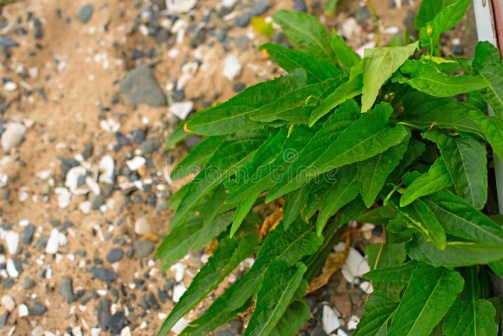Can you describe the plant in more detail? The plant featured in the image has long, slender leaves with pointed tips, showcasing a vibrant green color. Each leaf has a somewhat corrugated texture, which catches the sunlight beautifully and highlights the rich green hues. The leaves are densely packed, growing outward and giving the plant a lush, thriving appearance. This type of foliage is indicative of plants that are well-adapted to survive in rocky, less fertile soil, often found in rugged or hilly areas. Its resilience and adaptability add to the natural beauty and serenity of the scene. 